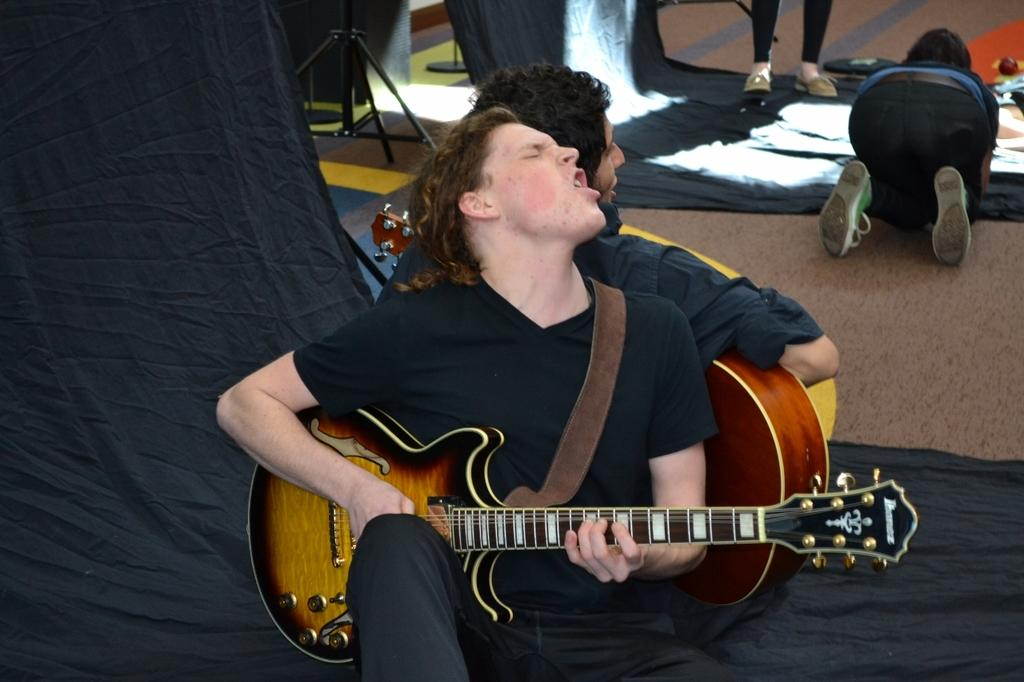How many people are present in the image? There are four people in the image. What are two of the people doing in the image? Two of the people are sitting. What are the sitting people holding in their hands? The two sitting people are holding guitars in their hands. How many horses can be seen in the image? There are no horses present in the image. What type of bead is being used by one of the people in the image? There is no bead visible in the image. 